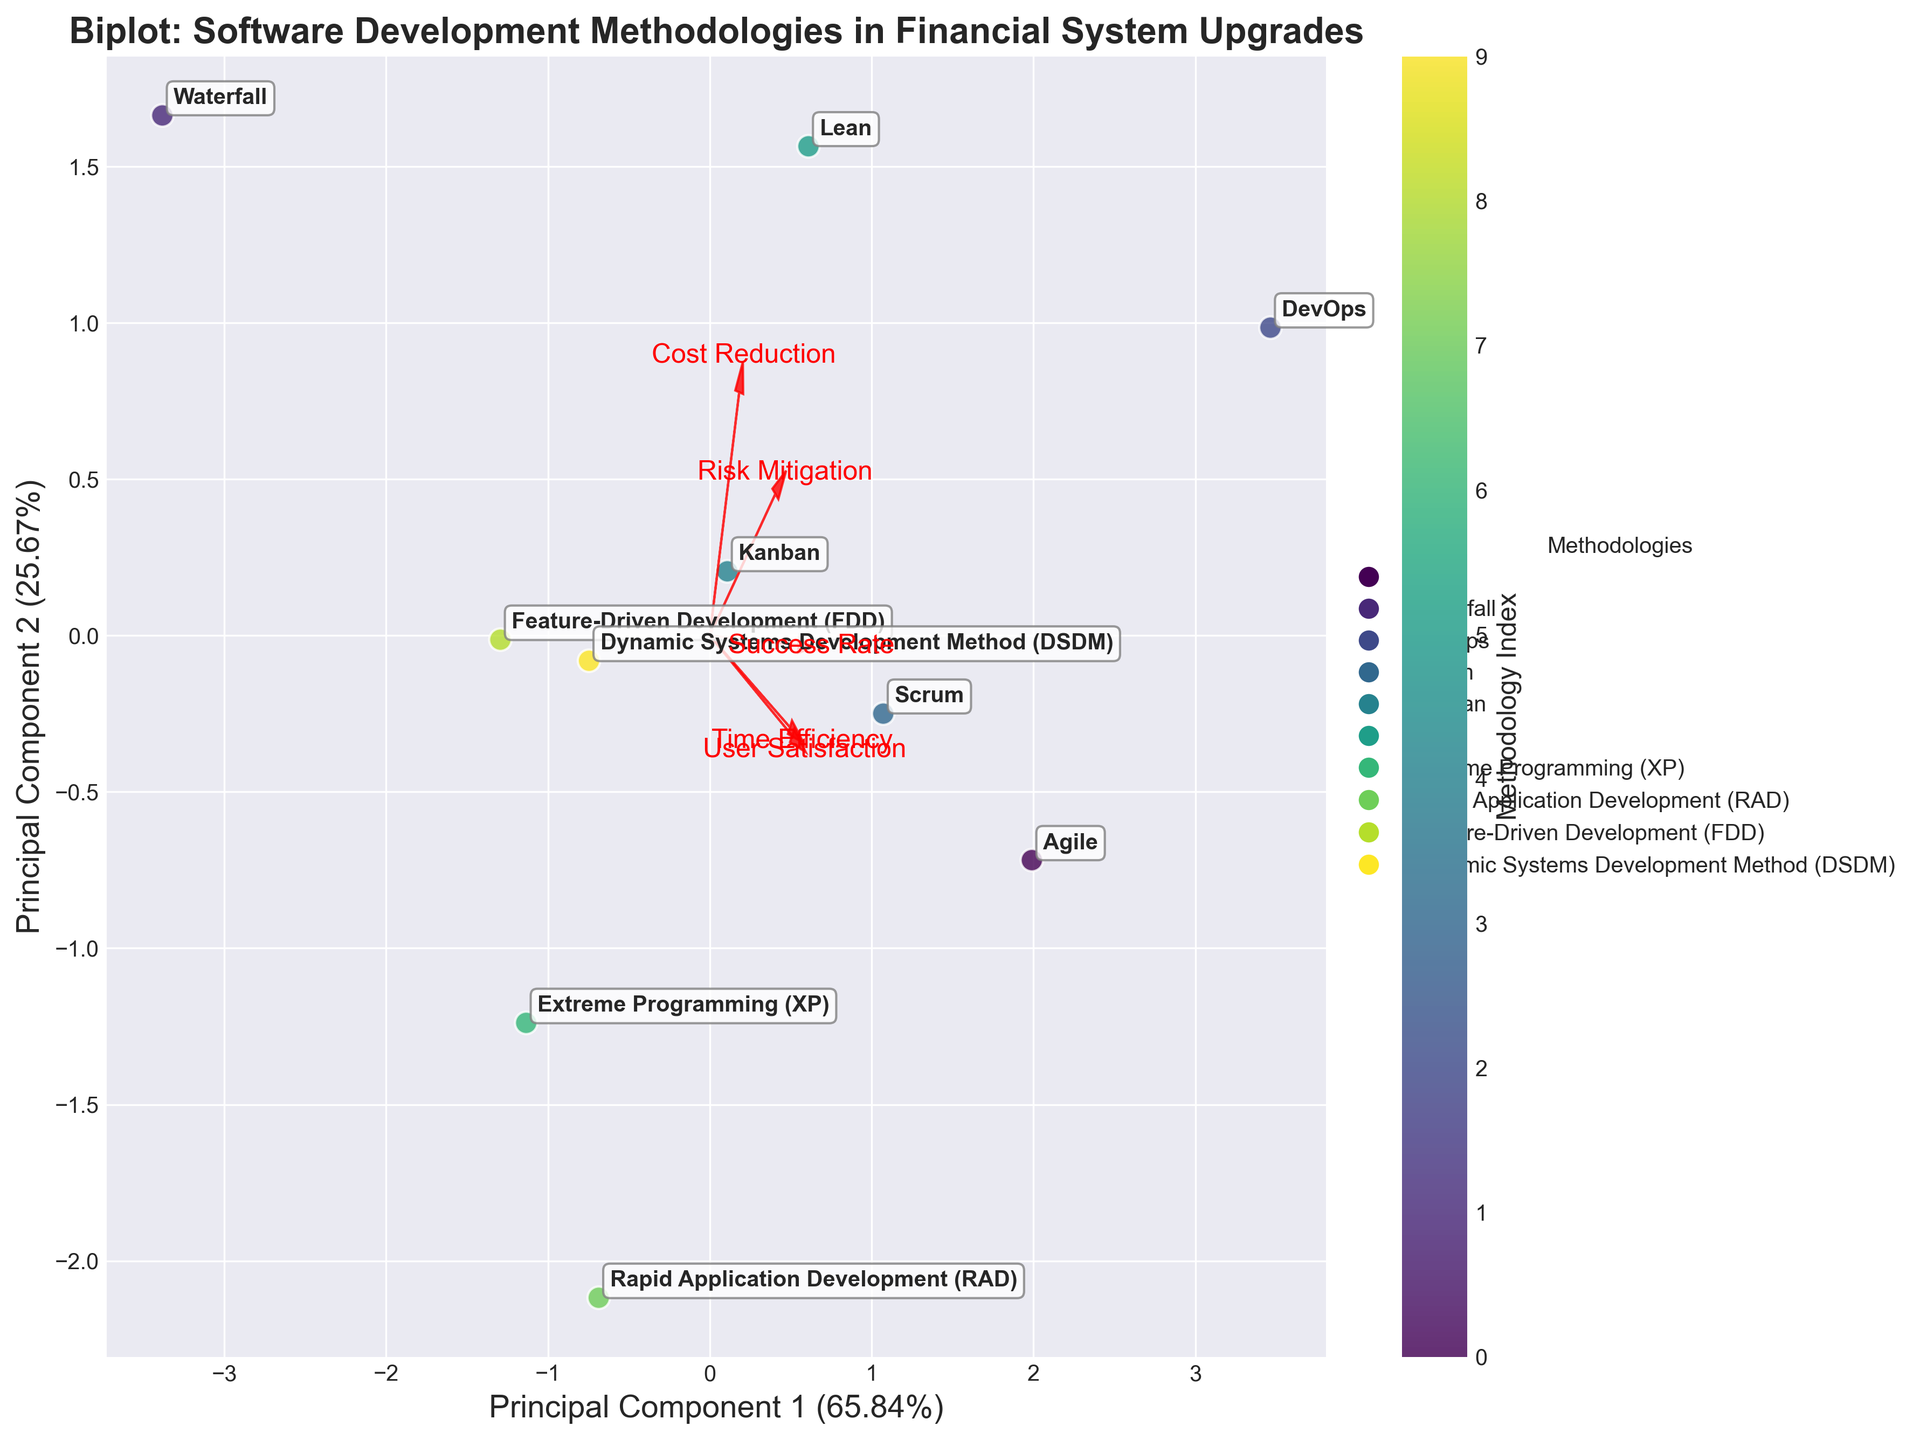How many methodologies are plotted in the figure? The number of methodologies can be determined by counting the different labeled points on the scatter plot. Each method is named and annotated on the biplot.
Answer: 10 What is the title of the figure? The title of the figure is typically displayed at the top of the plot.
Answer: Biplot: Software Development Methodologies in Financial System Upgrades Which principal component axis explains more variance? Look at the labels for each axis that include the percentage of variance explained by each principal component. Compare the two percentages.
Answer: Principal Component 1 Which methodology is plotted closest to the origin point (0,0) on the biplot? The origin point (0,0) is at the center of the plot. Identify the methodology name closest to this spot.
Answer: Feature-Driven Development (FDD) Which methodology shows the highest value for Time Efficiency? The direction and length of feature vectors represent the influence of each feature on the plotted methodologies. Look at the feature vector for Time Efficiency and see which methodology is plotted furthest along this direction.
Answer: DevOps Which two methodologies are closest to each other on the biplot? Identify the two methodologies that are plotted nearest to each other by visual inspection of their positions.
Answer: Lean and Scrum Which feature has the smallest influence on Principal Component 2? Look at the vectors representing features and see which one has the smallest projection on the Principal Component 2 (y-axis).
Answer: User Satisfaction If we rank methodologies by their ability in Risk Mitigation, which ranks highest? Look at the Risk Mitigation feature vector and see which methodology lies furthest in the direction of this vector.
Answer: DevOps Compare Agile and Waterfall methodologies based on Principal Component 1. Which one is more positive along this axis? Starting from the origin, see which methodology (Agile or Waterfall) lies further along the positive direction of the Principal Component 1 axis.
Answer: Agile Which feature contributes most positively to Principal Component 1? Look at the vectors representing each feature and determine which one has the longest projection on the Principal Component 1 (x-axis).
Answer: Time Efficiency 